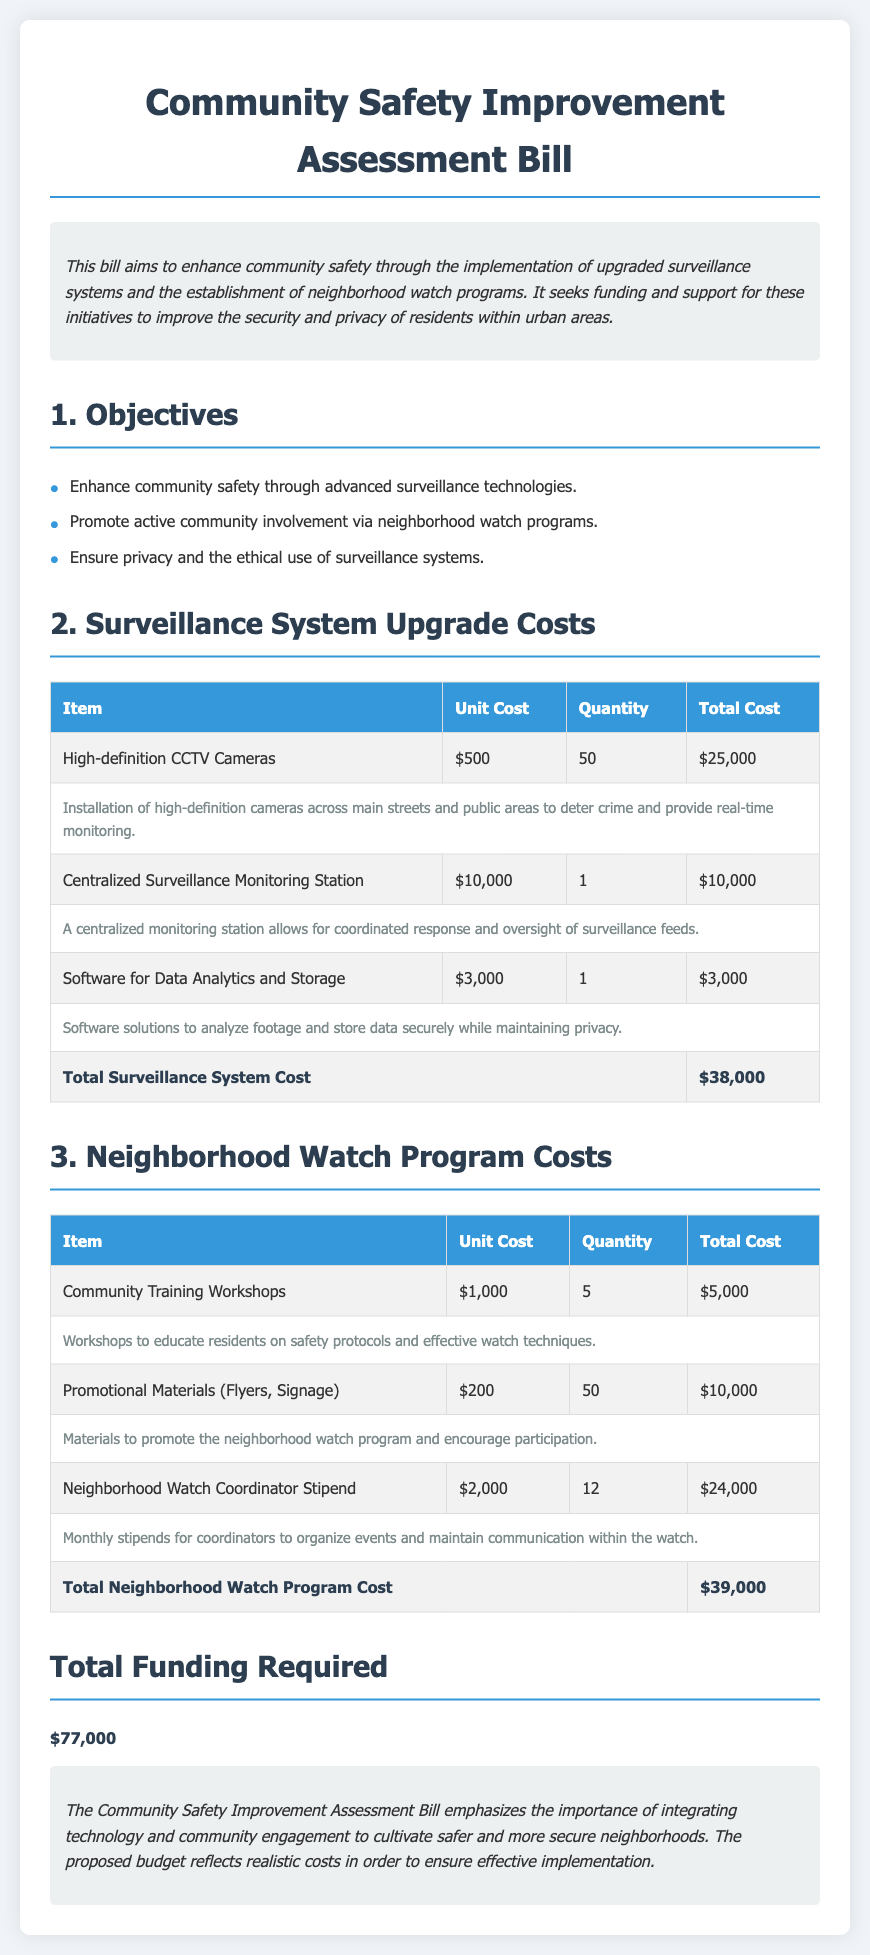What is the total cost for upgrading the surveillance system? The total cost for upgrading the surveillance system is calculated in the document, which is $38,000.
Answer: $38,000 How many high-definition CCTV cameras will be installed? The document states that 50 high-definition CCTV cameras will be installed.
Answer: 50 What is the cost for the Neighborhood Watch Coordinator Stipend? The cost for the Neighborhood Watch Coordinator Stipend is listed in the table as $2,000.
Answer: $2,000 How many community training workshops are planned? The document indicates that 5 community training workshops are planned.
Answer: 5 What is the total funding required for the entire initiative? The document summarizes the total funding required as $77,000.
Answer: $77,000 What type of monitoring station is referenced in the bill? The bill references a Centralized Surveillance Monitoring Station in its content.
Answer: Centralized Surveillance Monitoring Station What materials are included in the promotional items for the neighborhood watch? The document specifies that promotional materials include flyers and signage.
Answer: Flyers, Signage What is a key objective of the bill related to community involvement? The key objective related to community involvement is promoting active community involvement via neighborhood watch programs.
Answer: Promote active community involvement via neighborhood watch programs 